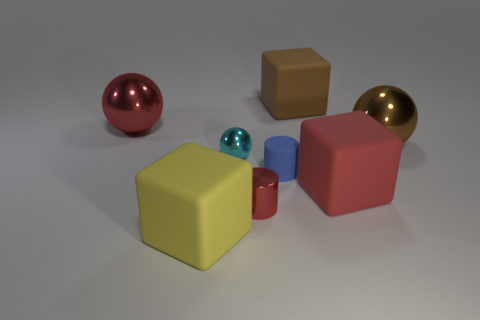Are there any objects of the same color as the small matte cylinder?
Offer a terse response. No. How many things are either big matte objects in front of the red metallic sphere or large cyan metallic balls?
Your response must be concise. 2. Is the material of the small sphere the same as the big brown object that is behind the brown sphere?
Ensure brevity in your answer.  No. What is the size of the rubber cube that is the same color as the shiny cylinder?
Offer a very short reply. Large. Is there a big yellow object made of the same material as the blue object?
Your response must be concise. Yes. How many things are matte things that are on the right side of the red metallic cylinder or rubber objects on the right side of the cyan ball?
Keep it short and to the point. 3. Does the red rubber object have the same shape as the big metallic thing that is to the left of the matte cylinder?
Provide a succinct answer. No. How many other objects are there of the same shape as the yellow object?
Offer a very short reply. 2. How many things are either tiny yellow rubber balls or blocks?
Keep it short and to the point. 3. Is the color of the tiny rubber thing the same as the small ball?
Provide a short and direct response. No. 